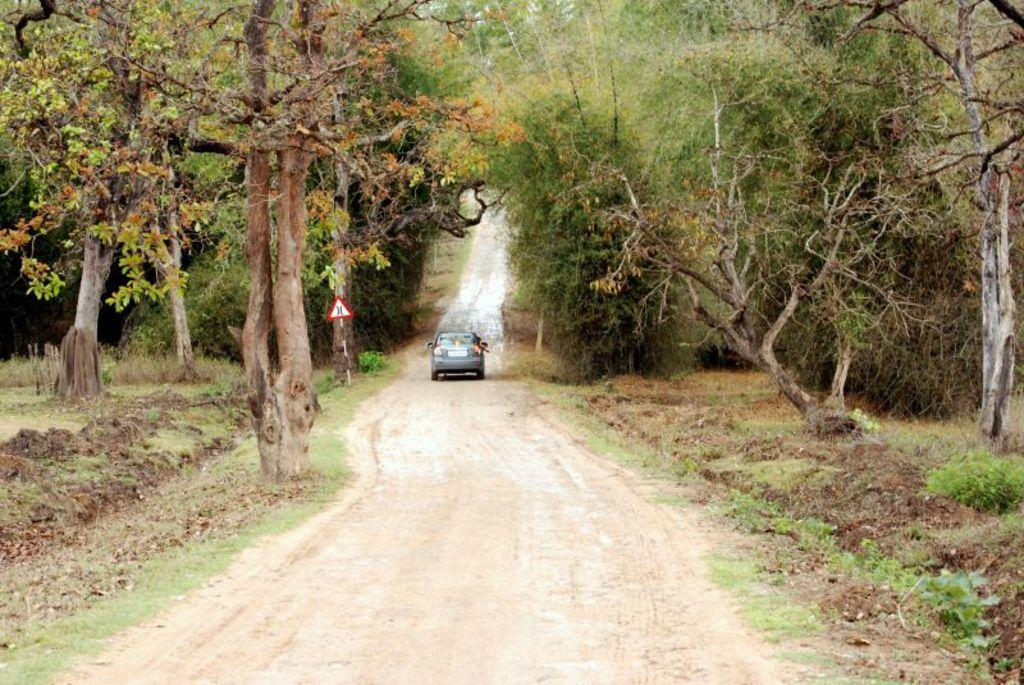What is the main subject in the center of the image? There is a car and a board in the center of the image. What can be seen in the background of the image? There are trees visible in the background of the image. What is located at the bottom of the image? There is a rod at the bottom of the image. How many friends are sitting in the car with the governor in the image? There is no mention of friends or any individuals in the image. 